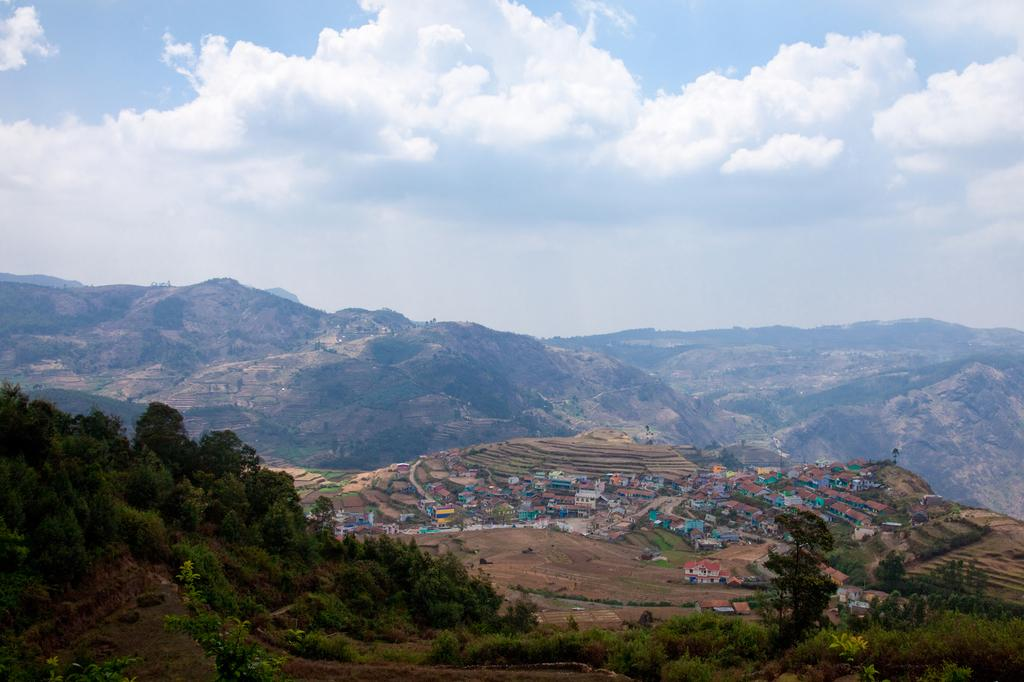What type of vegetation can be seen in the image? There are trees and plants in the image. What type of structures are present in the image? There are houses in the image. What type of ground cover is visible in the image? There is grass in the image. What type of terrain can be seen in the image? There are hills in the image. What is visible in the sky in the image? There is sky visible in the image, with clouds present. How many patches are being sewn by the sisters in the image? There are no patches or sisters present in the image. What type of pump is visible in the image? There is no pump present in the image. 